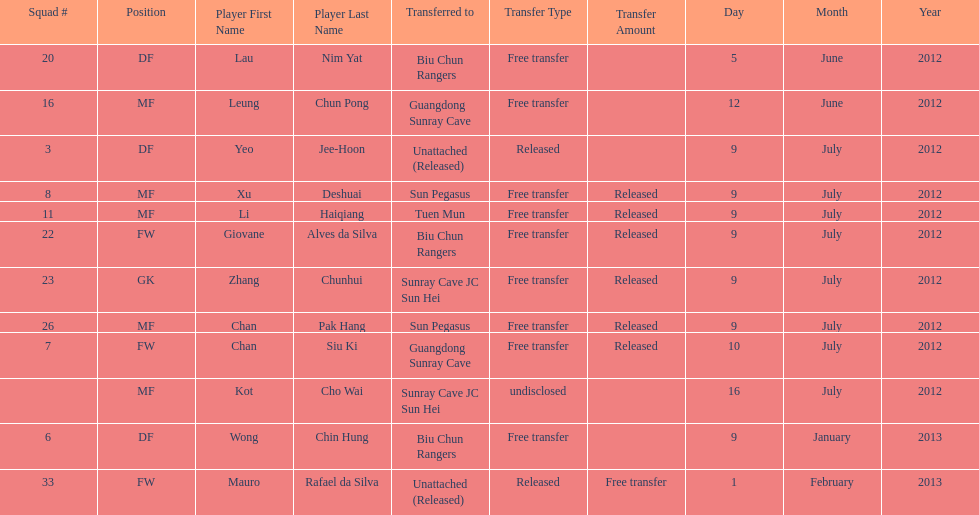What is the total number of players listed? 12. 